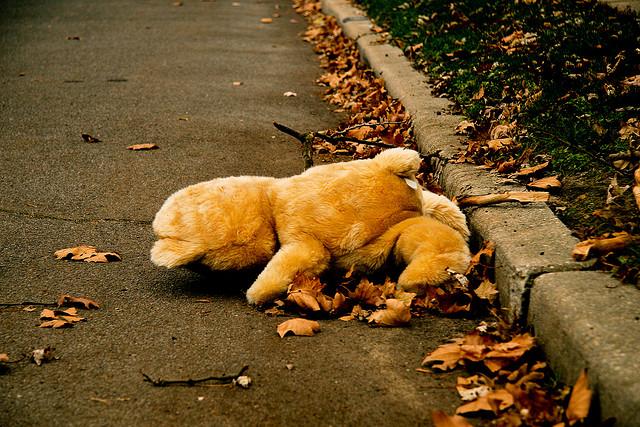What is scattered across the ground?
Answer briefly. Leaves. What color is the bear?
Write a very short answer. Tan. How many bears are on the ground?
Keep it brief. 1. 